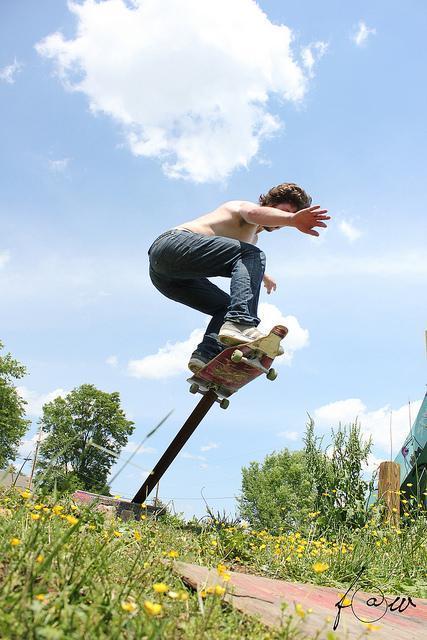How many skis does this person have?
Give a very brief answer. 0. 